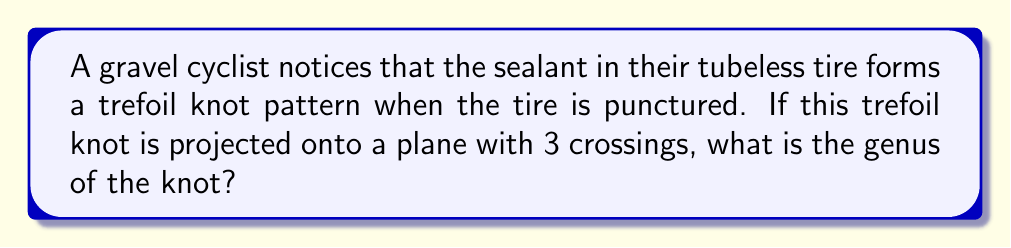Solve this math problem. To determine the genus of the trefoil knot, we'll follow these steps:

1. Recall the formula for the genus of a knot:
   $$g = \frac{1}{2}(c - n + 1)$$
   where $g$ is the genus, $c$ is the number of crossings, and $n$ is the number of components.

2. For the trefoil knot:
   - The number of crossings, $c = 3$
   - The number of components, $n = 1$ (as it's a single closed curve)

3. Substitute these values into the formula:
   $$g = \frac{1}{2}(3 - 1 + 1)$$

4. Simplify:
   $$g = \frac{1}{2}(3)$$
   $$g = \frac{3}{2}$$

5. Since the genus must be an integer, we round up to the nearest whole number:
   $$g = 1$$

Therefore, the genus of the trefoil knot formed by the tubeless tire sealant pattern is 1.
Answer: 1 